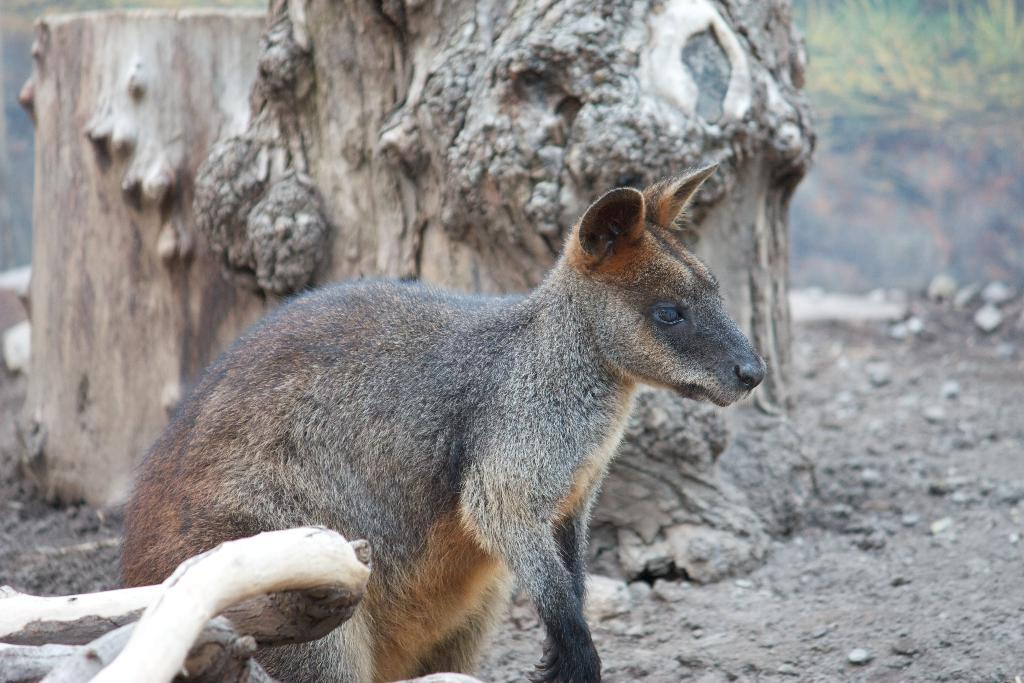What type of animal can be seen in the image? There is an animal in the image, but its specific type cannot be determined from the provided facts. What colors are present on the animal? The animal has black and brown color. What is the animal doing in the image? The animal is looking at the ground. What can be seen in the image besides the animal? There is a tree stem in the image. What is the color of the tree stem? The tree stem has a brown color. What type of suit is the animal wearing in the image? There is no suit present in the image; the animal is not wearing any clothing. What process is the animal undergoing in the image? There is no process mentioned or implied in the image; the animal is simply looking at the ground. 